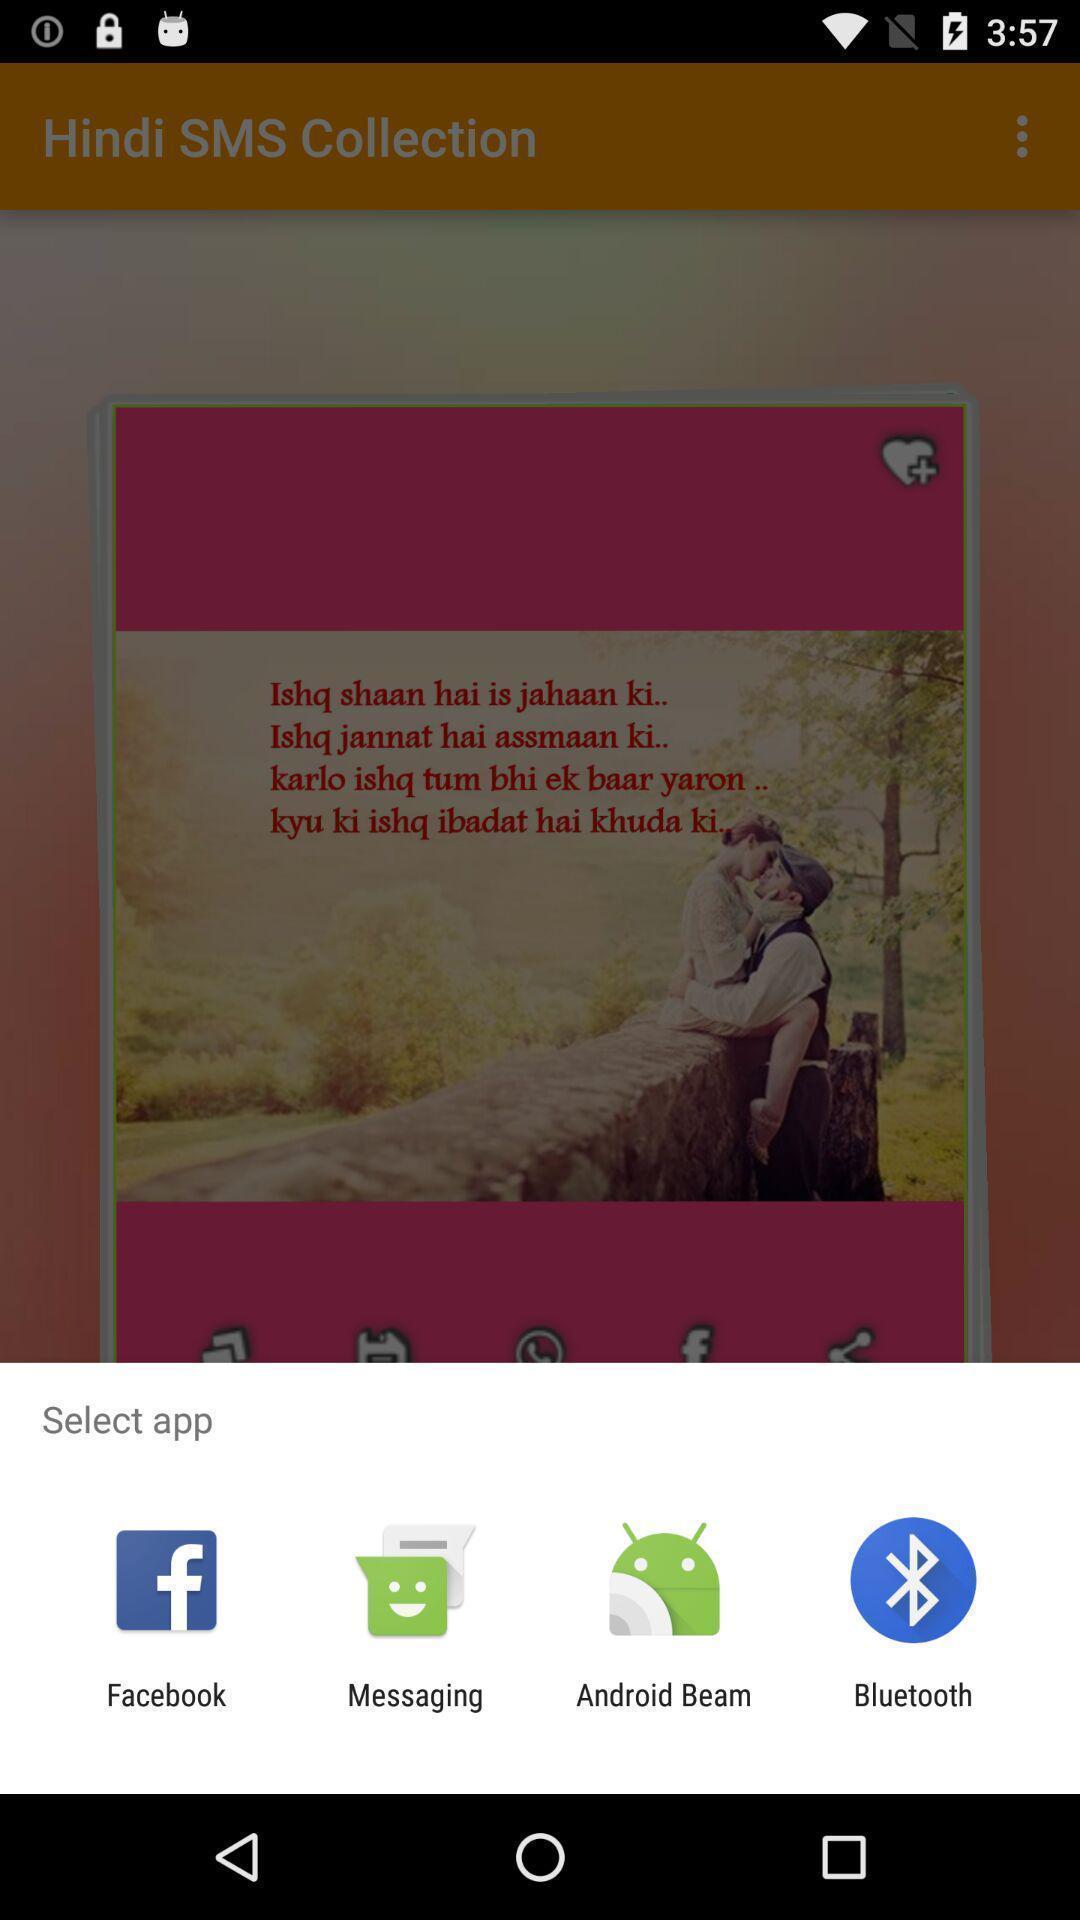Provide a textual representation of this image. Popup of applications to share the information. 